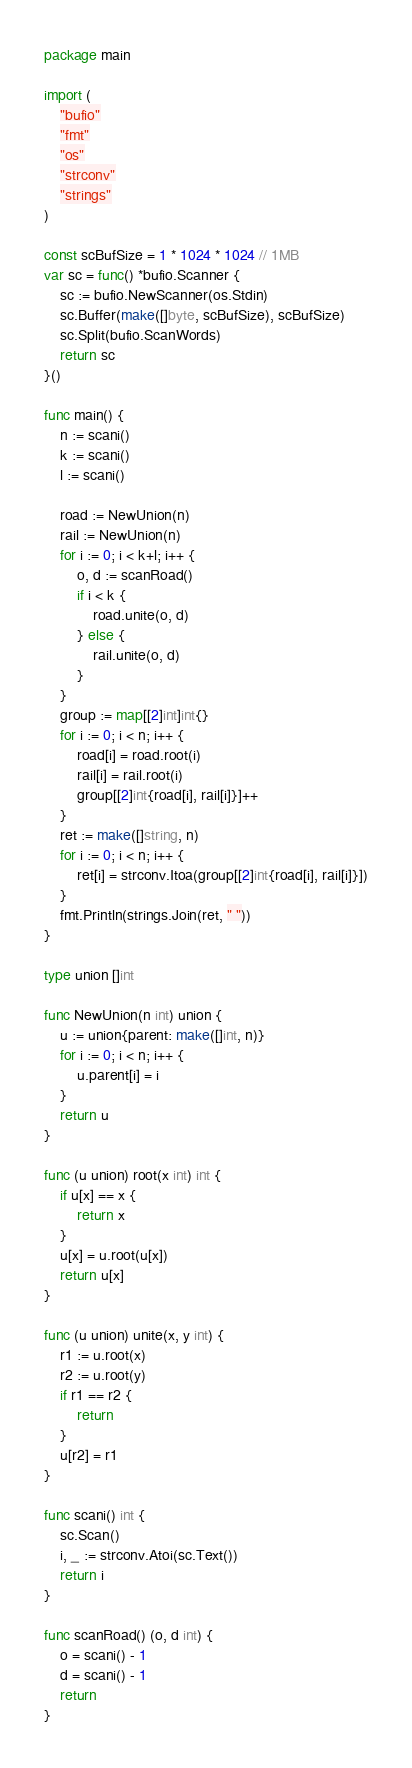Convert code to text. <code><loc_0><loc_0><loc_500><loc_500><_Go_>package main

import (
	"bufio"
	"fmt"
	"os"
	"strconv"
	"strings"
)

const scBufSize = 1 * 1024 * 1024 // 1MB
var sc = func() *bufio.Scanner {
	sc := bufio.NewScanner(os.Stdin)
	sc.Buffer(make([]byte, scBufSize), scBufSize)
	sc.Split(bufio.ScanWords)
	return sc
}()

func main() {
	n := scani()
	k := scani()
	l := scani()

	road := NewUnion(n)
	rail := NewUnion(n)
	for i := 0; i < k+l; i++ {
		o, d := scanRoad()
		if i < k {
			road.unite(o, d)
		} else {
			rail.unite(o, d)
		}
	}
	group := map[[2]int]int{}
	for i := 0; i < n; i++ {
		road[i] = road.root(i)
		rail[i] = rail.root(i)
		group[[2]int{road[i], rail[i]}]++
	}
	ret := make([]string, n)
	for i := 0; i < n; i++ {
		ret[i] = strconv.Itoa(group[[2]int{road[i], rail[i]}])
	}
	fmt.Println(strings.Join(ret, " "))
}

type union []int

func NewUnion(n int) union {
	u := union{parent: make([]int, n)}
	for i := 0; i < n; i++ {
		u.parent[i] = i
	}
	return u
}

func (u union) root(x int) int {
	if u[x] == x {
		return x
	}
	u[x] = u.root(u[x])
	return u[x]
}

func (u union) unite(x, y int) {
	r1 := u.root(x)
	r2 := u.root(y)
	if r1 == r2 {
		return
	}
	u[r2] = r1
}

func scani() int {
	sc.Scan()
	i, _ := strconv.Atoi(sc.Text())
	return i
}

func scanRoad() (o, d int) {
	o = scani() - 1
	d = scani() - 1
	return
}
</code> 